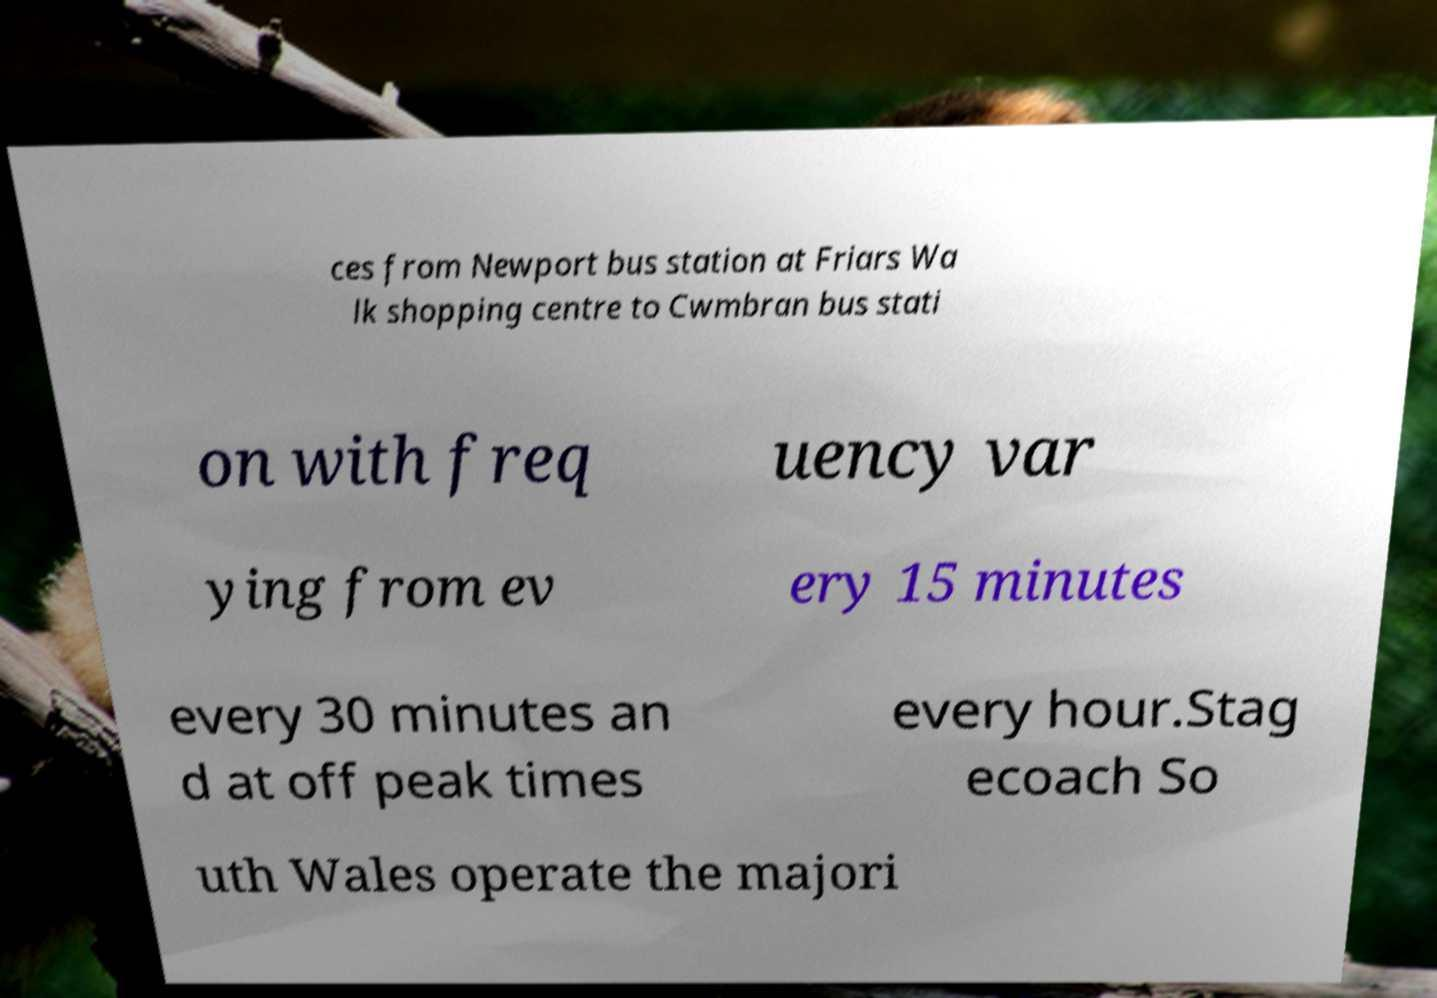There's text embedded in this image that I need extracted. Can you transcribe it verbatim? ces from Newport bus station at Friars Wa lk shopping centre to Cwmbran bus stati on with freq uency var ying from ev ery 15 minutes every 30 minutes an d at off peak times every hour.Stag ecoach So uth Wales operate the majori 